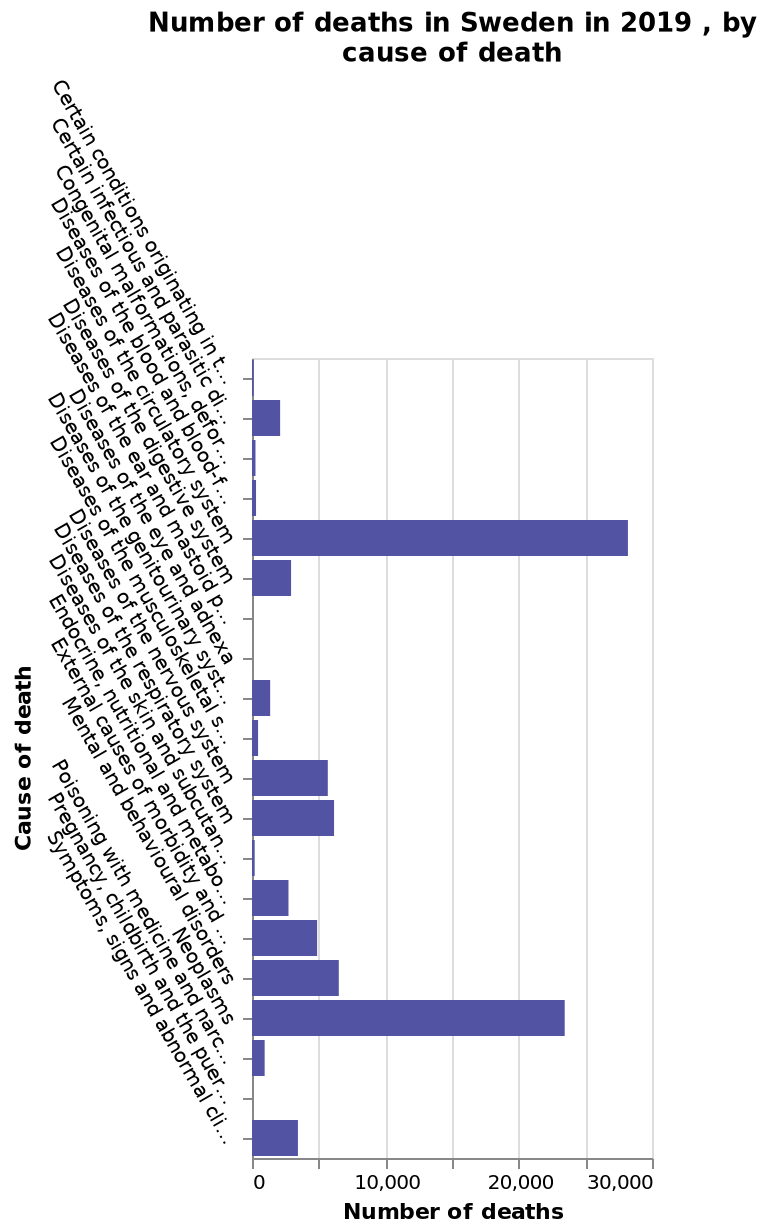<image>
Which system is primarily affected by the diseases causing death in Sweden?  The circulatory system. Are there any other causes of death that surpass diseases of the circulatory system in Sweden? No, they are the single greatest cause of death in the country. What is the leading factor behind most deaths in Sweden?  Diseases related to the circulatory system. 